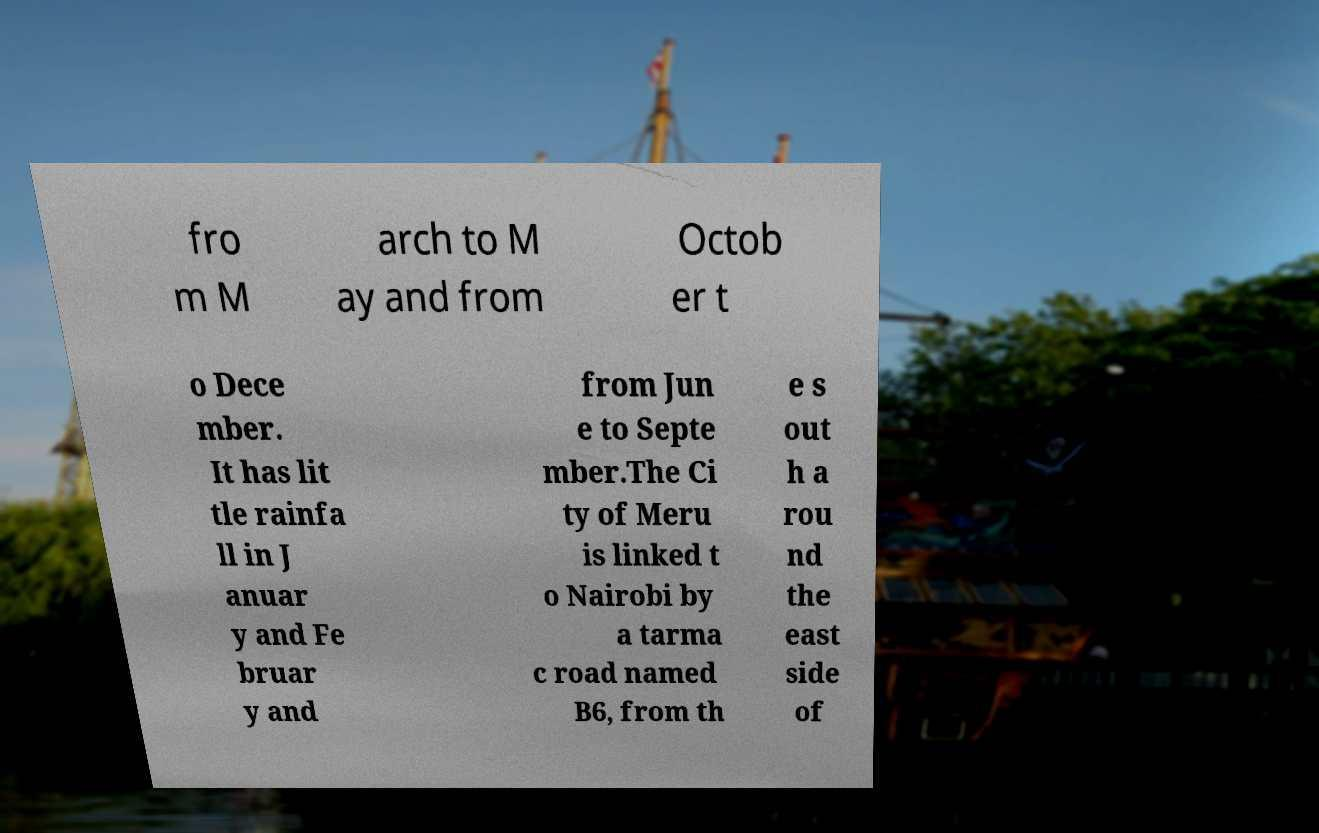There's text embedded in this image that I need extracted. Can you transcribe it verbatim? fro m M arch to M ay and from Octob er t o Dece mber. It has lit tle rainfa ll in J anuar y and Fe bruar y and from Jun e to Septe mber.The Ci ty of Meru is linked t o Nairobi by a tarma c road named B6, from th e s out h a rou nd the east side of 